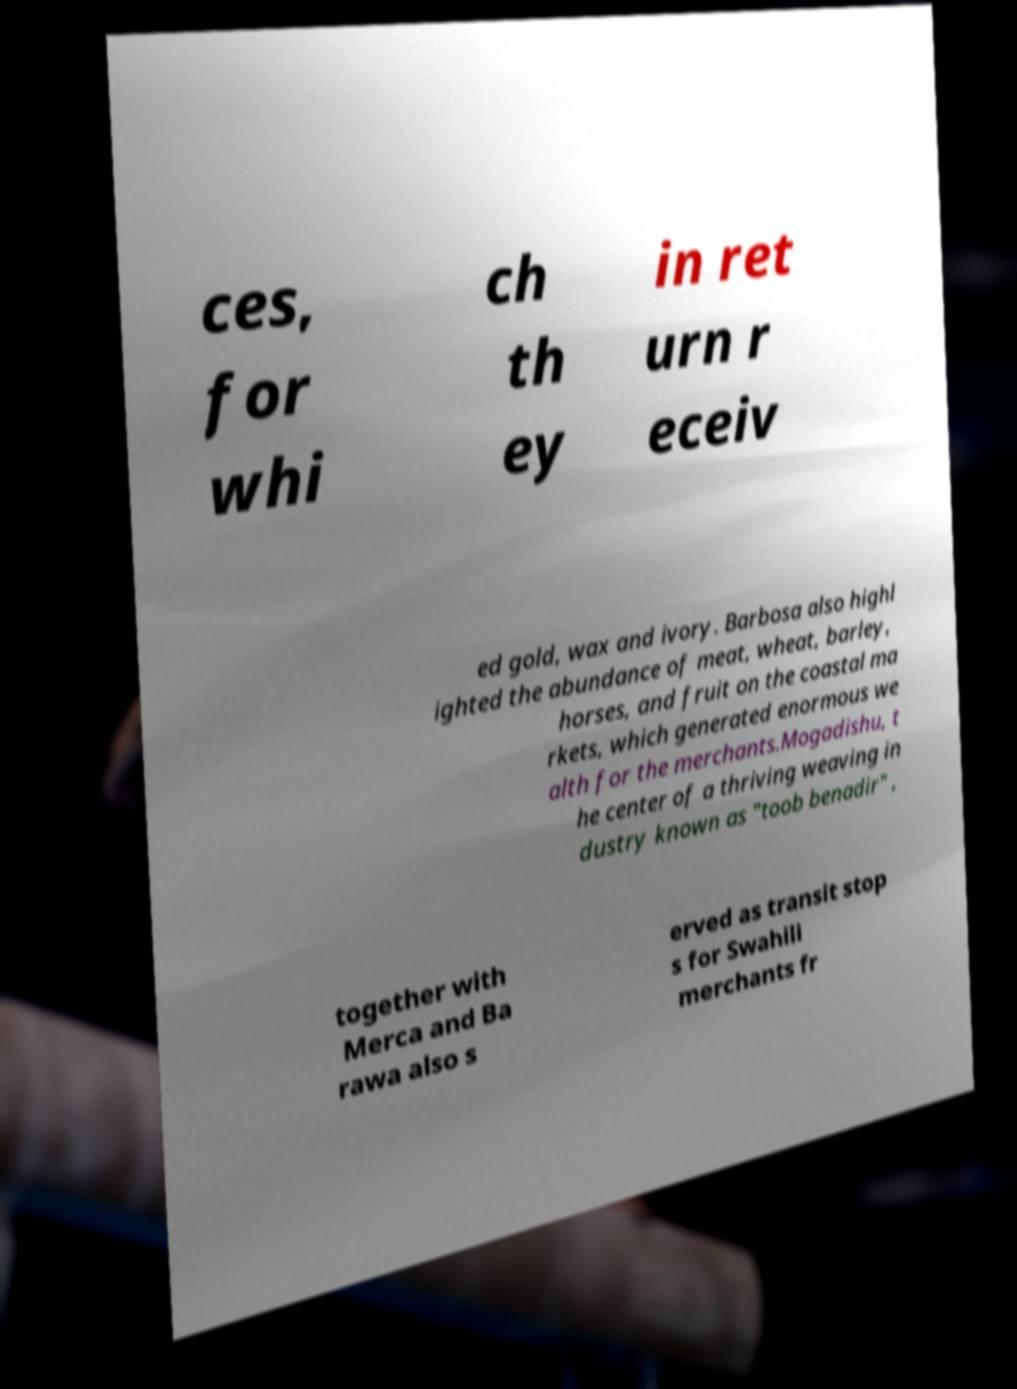What messages or text are displayed in this image? I need them in a readable, typed format. ces, for whi ch th ey in ret urn r eceiv ed gold, wax and ivory. Barbosa also highl ighted the abundance of meat, wheat, barley, horses, and fruit on the coastal ma rkets, which generated enormous we alth for the merchants.Mogadishu, t he center of a thriving weaving in dustry known as "toob benadir" , together with Merca and Ba rawa also s erved as transit stop s for Swahili merchants fr 